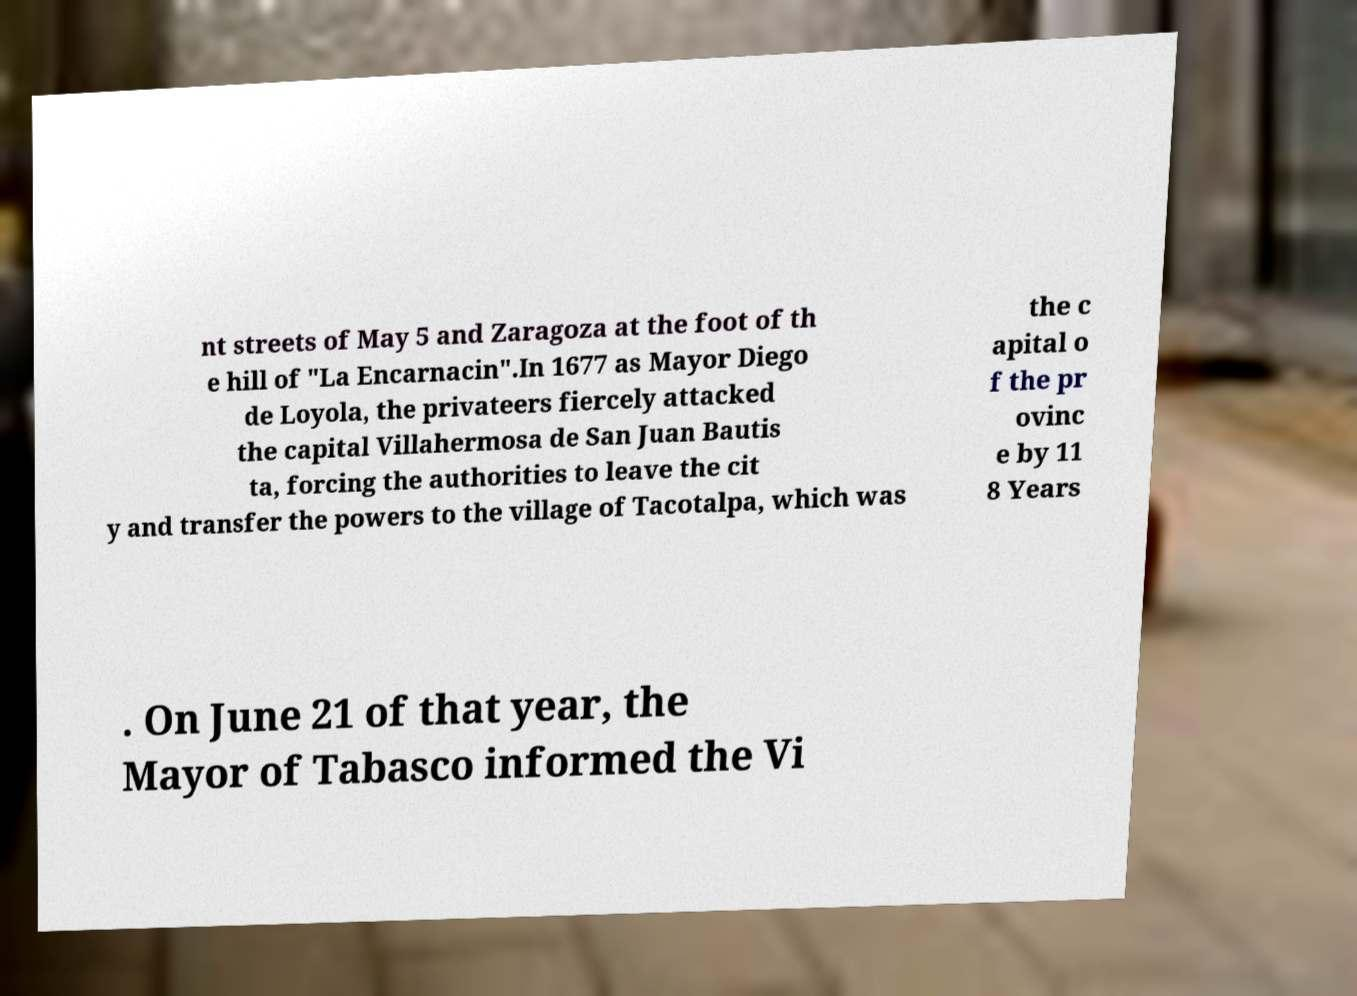There's text embedded in this image that I need extracted. Can you transcribe it verbatim? nt streets of May 5 and Zaragoza at the foot of th e hill of "La Encarnacin".In 1677 as Mayor Diego de Loyola, the privateers fiercely attacked the capital Villahermosa de San Juan Bautis ta, forcing the authorities to leave the cit y and transfer the powers to the village of Tacotalpa, which was the c apital o f the pr ovinc e by 11 8 Years . On June 21 of that year, the Mayor of Tabasco informed the Vi 